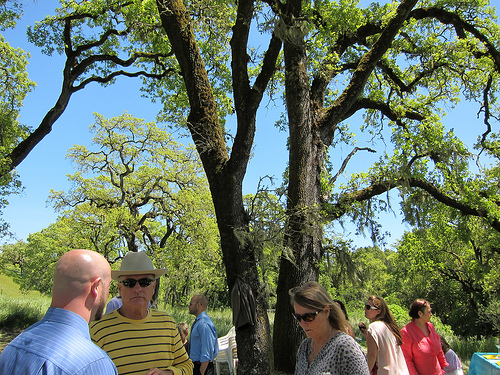<image>
Is there a cap on the tree? No. The cap is not positioned on the tree. They may be near each other, but the cap is not supported by or resting on top of the tree. 